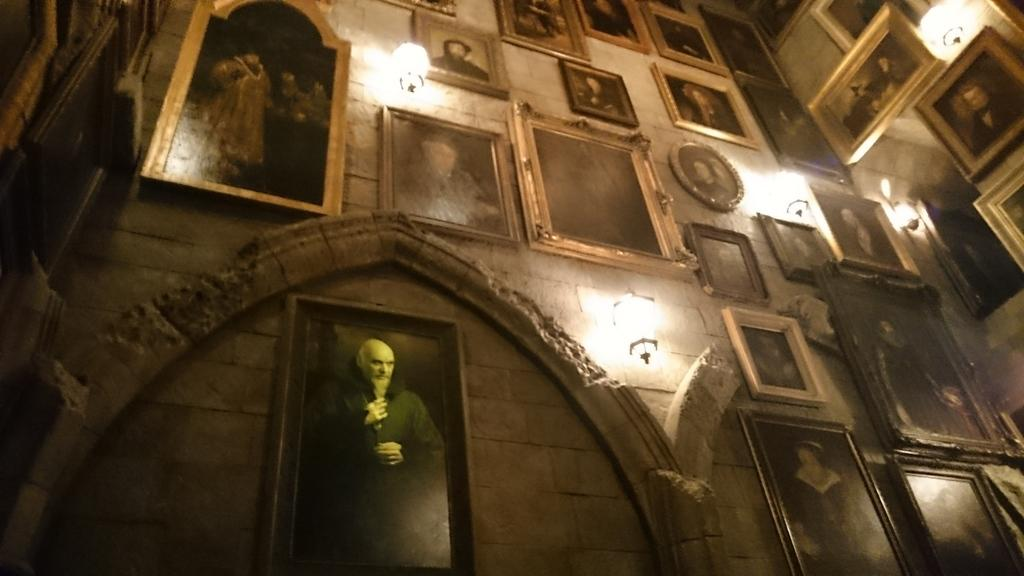What is attached to the wall in the image? There are photo frames attached to the wall in the image. What else can be seen in the image besides the photo frames? There are lights visible in the image. How many cows are present in the image? There are no cows present in the image. What type of material is the station made of in the image? There is no station present in the image. 